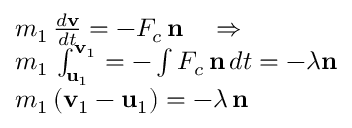Convert formula to latex. <formula><loc_0><loc_0><loc_500><loc_500>\begin{array} { r l } & { m _ { 1 } \, \frac { d \mathbf v } { d t } = - F _ { c } \, \mathbf n \quad \Rightarrow } \\ & { m _ { 1 } \, \int _ { \mathbf u _ { 1 } } ^ { \mathbf v _ { 1 } } = - \int F _ { c } \, \mathbf n \, d t = - \lambda n } \\ & { m _ { 1 } \, ( \mathbf v _ { 1 } - \mathbf u _ { 1 } ) = - \lambda \, \mathbf n } \end{array}</formula> 